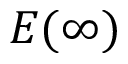<formula> <loc_0><loc_0><loc_500><loc_500>E ( \infty )</formula> 